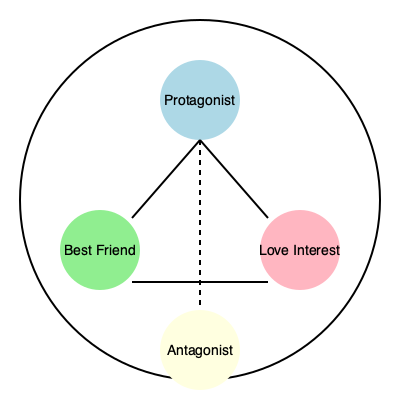In the context of your small-town novel, analyze the character relationship network diagram provided. How might the protagonist's connection to the antagonist (represented by the dashed line) influence the narrative structure and character development throughout the story? Consider the potential impact on the best friend and love interest relationships as well. To analyze this character relationship network diagram in the context of a small-town novel, we need to consider several key aspects:

1. Central position of the protagonist: The protagonist is at the top of the diagram, indicating their central role in the story.

2. Solid lines vs. dashed line:
   - Solid lines connect the protagonist to the best friend and love interest, suggesting strong, established relationships.
   - The dashed line between the protagonist and antagonist implies a complex, potentially evolving relationship.

3. Antagonist's position: The antagonist is directly opposite the protagonist, suggesting a direct conflict or opposition.

4. Triangular relationships:
   - Protagonist-Best Friend-Love Interest: This triangle implies potential for support, conflict, or character growth.
   - Protagonist-Antagonist-Best Friend/Love Interest: These triangles suggest the antagonist might influence other relationships.

5. Narrative structure implications:
   - The dashed line to the antagonist could represent a gradual revelation of conflict or a changing relationship over time.
   - This structure might lead to a non-linear narrative, with flashbacks or shifting perspectives to explore the antagonist's connection.

6. Character development opportunities:
   - The protagonist may struggle with their connection to the antagonist, leading to internal conflict and growth.
   - The best friend and love interest might be forced to confront their own relationships with the antagonist, adding depth to their characters.

7. Small-town dynamics:
   - In a small town, these interconnected relationships could create complex social dynamics and secrets.
   - The antagonist's connection to all characters might represent shared history or community ties unique to small-town life.

8. Potential plot developments:
   - The dashed line could foreshadow a reveal about the protagonist's past or a hidden connection to the antagonist.
   - It might also suggest a potential redemption arc for the antagonist or a moral dilemma for the protagonist.

By carefully considering these elements, the author can craft a rich, interconnected narrative that explores the complexities of small-town relationships and personal growth.
Answer: The dashed line between protagonist and antagonist suggests a complex, evolving relationship that can drive character development, create narrative tension, and influence other relationships, potentially leading to a non-linear story structure that explores the interconnected dynamics of small-town life. 